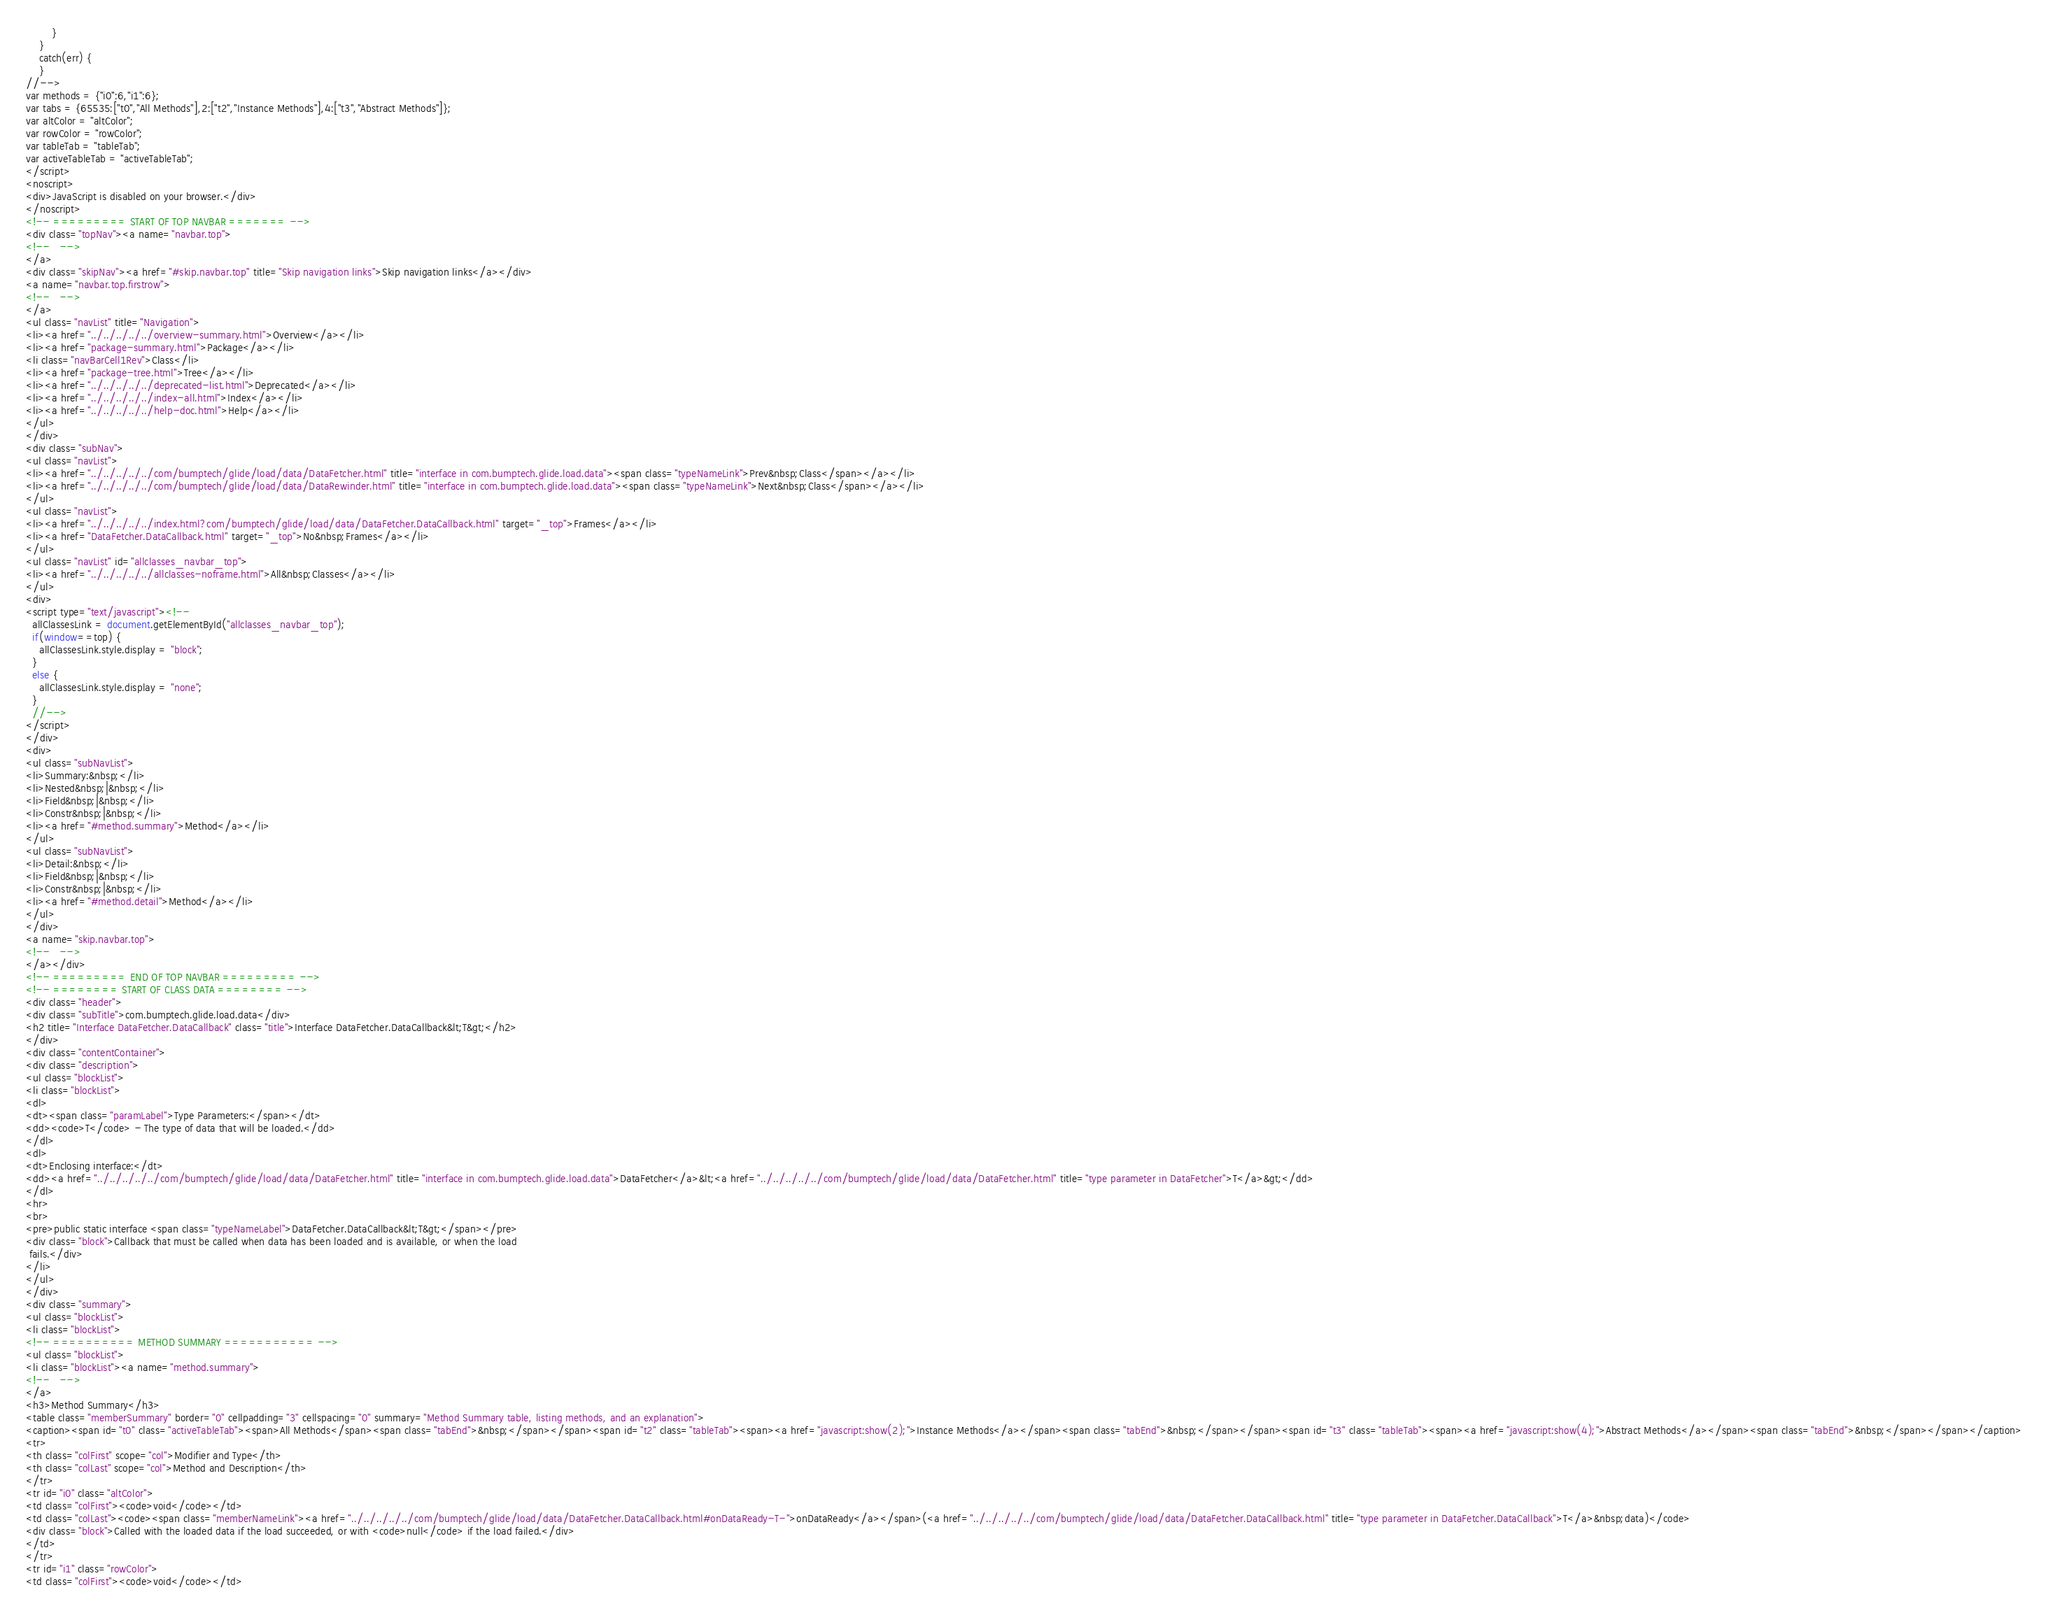Convert code to text. <code><loc_0><loc_0><loc_500><loc_500><_HTML_>        }
    }
    catch(err) {
    }
//-->
var methods = {"i0":6,"i1":6};
var tabs = {65535:["t0","All Methods"],2:["t2","Instance Methods"],4:["t3","Abstract Methods"]};
var altColor = "altColor";
var rowColor = "rowColor";
var tableTab = "tableTab";
var activeTableTab = "activeTableTab";
</script>
<noscript>
<div>JavaScript is disabled on your browser.</div>
</noscript>
<!-- ========= START OF TOP NAVBAR ======= -->
<div class="topNav"><a name="navbar.top">
<!--   -->
</a>
<div class="skipNav"><a href="#skip.navbar.top" title="Skip navigation links">Skip navigation links</a></div>
<a name="navbar.top.firstrow">
<!--   -->
</a>
<ul class="navList" title="Navigation">
<li><a href="../../../../../overview-summary.html">Overview</a></li>
<li><a href="package-summary.html">Package</a></li>
<li class="navBarCell1Rev">Class</li>
<li><a href="package-tree.html">Tree</a></li>
<li><a href="../../../../../deprecated-list.html">Deprecated</a></li>
<li><a href="../../../../../index-all.html">Index</a></li>
<li><a href="../../../../../help-doc.html">Help</a></li>
</ul>
</div>
<div class="subNav">
<ul class="navList">
<li><a href="../../../../../com/bumptech/glide/load/data/DataFetcher.html" title="interface in com.bumptech.glide.load.data"><span class="typeNameLink">Prev&nbsp;Class</span></a></li>
<li><a href="../../../../../com/bumptech/glide/load/data/DataRewinder.html" title="interface in com.bumptech.glide.load.data"><span class="typeNameLink">Next&nbsp;Class</span></a></li>
</ul>
<ul class="navList">
<li><a href="../../../../../index.html?com/bumptech/glide/load/data/DataFetcher.DataCallback.html" target="_top">Frames</a></li>
<li><a href="DataFetcher.DataCallback.html" target="_top">No&nbsp;Frames</a></li>
</ul>
<ul class="navList" id="allclasses_navbar_top">
<li><a href="../../../../../allclasses-noframe.html">All&nbsp;Classes</a></li>
</ul>
<div>
<script type="text/javascript"><!--
  allClassesLink = document.getElementById("allclasses_navbar_top");
  if(window==top) {
    allClassesLink.style.display = "block";
  }
  else {
    allClassesLink.style.display = "none";
  }
  //-->
</script>
</div>
<div>
<ul class="subNavList">
<li>Summary:&nbsp;</li>
<li>Nested&nbsp;|&nbsp;</li>
<li>Field&nbsp;|&nbsp;</li>
<li>Constr&nbsp;|&nbsp;</li>
<li><a href="#method.summary">Method</a></li>
</ul>
<ul class="subNavList">
<li>Detail:&nbsp;</li>
<li>Field&nbsp;|&nbsp;</li>
<li>Constr&nbsp;|&nbsp;</li>
<li><a href="#method.detail">Method</a></li>
</ul>
</div>
<a name="skip.navbar.top">
<!--   -->
</a></div>
<!-- ========= END OF TOP NAVBAR ========= -->
<!-- ======== START OF CLASS DATA ======== -->
<div class="header">
<div class="subTitle">com.bumptech.glide.load.data</div>
<h2 title="Interface DataFetcher.DataCallback" class="title">Interface DataFetcher.DataCallback&lt;T&gt;</h2>
</div>
<div class="contentContainer">
<div class="description">
<ul class="blockList">
<li class="blockList">
<dl>
<dt><span class="paramLabel">Type Parameters:</span></dt>
<dd><code>T</code> - The type of data that will be loaded.</dd>
</dl>
<dl>
<dt>Enclosing interface:</dt>
<dd><a href="../../../../../com/bumptech/glide/load/data/DataFetcher.html" title="interface in com.bumptech.glide.load.data">DataFetcher</a>&lt;<a href="../../../../../com/bumptech/glide/load/data/DataFetcher.html" title="type parameter in DataFetcher">T</a>&gt;</dd>
</dl>
<hr>
<br>
<pre>public static interface <span class="typeNameLabel">DataFetcher.DataCallback&lt;T&gt;</span></pre>
<div class="block">Callback that must be called when data has been loaded and is available, or when the load
 fails.</div>
</li>
</ul>
</div>
<div class="summary">
<ul class="blockList">
<li class="blockList">
<!-- ========== METHOD SUMMARY =========== -->
<ul class="blockList">
<li class="blockList"><a name="method.summary">
<!--   -->
</a>
<h3>Method Summary</h3>
<table class="memberSummary" border="0" cellpadding="3" cellspacing="0" summary="Method Summary table, listing methods, and an explanation">
<caption><span id="t0" class="activeTableTab"><span>All Methods</span><span class="tabEnd">&nbsp;</span></span><span id="t2" class="tableTab"><span><a href="javascript:show(2);">Instance Methods</a></span><span class="tabEnd">&nbsp;</span></span><span id="t3" class="tableTab"><span><a href="javascript:show(4);">Abstract Methods</a></span><span class="tabEnd">&nbsp;</span></span></caption>
<tr>
<th class="colFirst" scope="col">Modifier and Type</th>
<th class="colLast" scope="col">Method and Description</th>
</tr>
<tr id="i0" class="altColor">
<td class="colFirst"><code>void</code></td>
<td class="colLast"><code><span class="memberNameLink"><a href="../../../../../com/bumptech/glide/load/data/DataFetcher.DataCallback.html#onDataReady-T-">onDataReady</a></span>(<a href="../../../../../com/bumptech/glide/load/data/DataFetcher.DataCallback.html" title="type parameter in DataFetcher.DataCallback">T</a>&nbsp;data)</code>
<div class="block">Called with the loaded data if the load succeeded, or with <code>null</code> if the load failed.</div>
</td>
</tr>
<tr id="i1" class="rowColor">
<td class="colFirst"><code>void</code></td></code> 